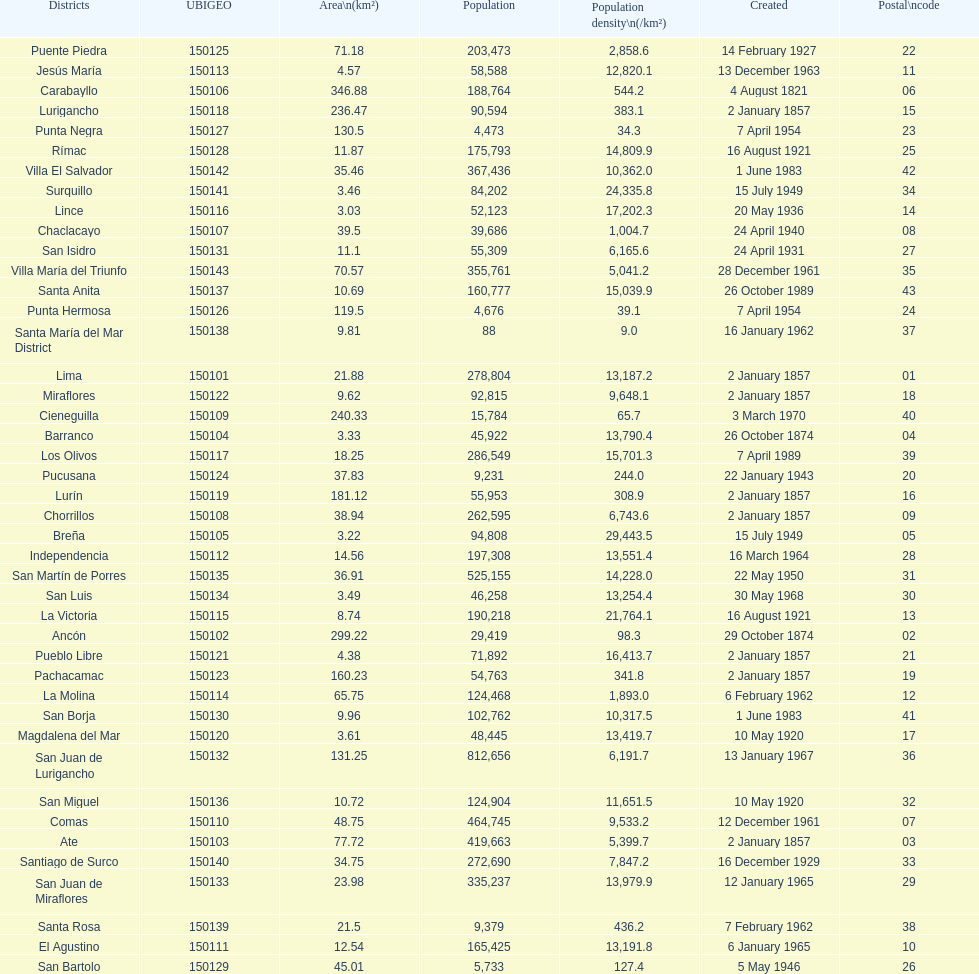What district has the least amount of population? Santa María del Mar District. 